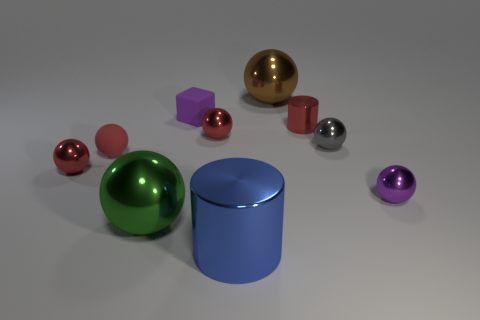Do the brown metal ball and the rubber ball have the same size?
Give a very brief answer. No. What number of gray things are either tiny metal balls or large rubber things?
Give a very brief answer. 1. How many matte things are either large blue cylinders or small red objects?
Give a very brief answer. 1. Are there any gray matte blocks?
Make the answer very short. No. Is the big brown metallic object the same shape as the gray object?
Make the answer very short. Yes. What number of big green metal things are right of the big ball that is in front of the matte object that is in front of the gray shiny sphere?
Offer a very short reply. 0. There is a object that is behind the red metal cylinder and left of the big blue cylinder; what material is it?
Give a very brief answer. Rubber. There is a sphere that is behind the small gray metal thing and in front of the brown sphere; what color is it?
Ensure brevity in your answer.  Red. Is there anything else that has the same color as the small cylinder?
Ensure brevity in your answer.  Yes. There is a small purple object to the right of the big shiny thing in front of the large sphere in front of the big brown ball; what is its shape?
Offer a very short reply. Sphere. 